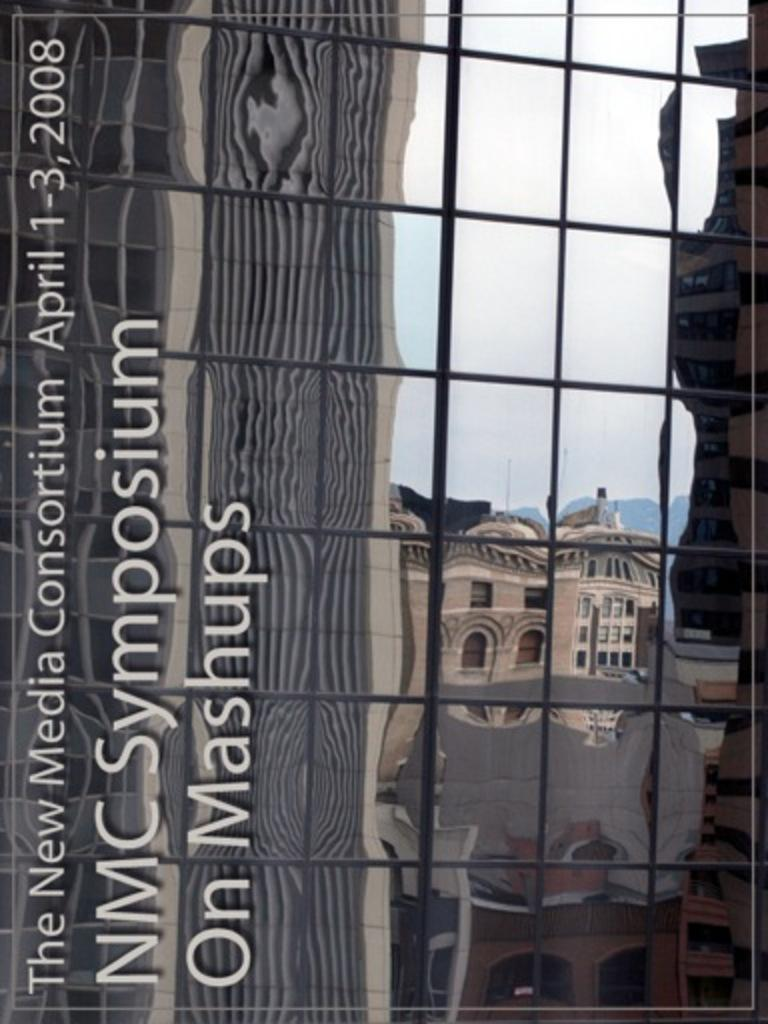What is located in the middle of the image? There is a glass in the middle of the image. What can be seen in the reflections on the glass? The glass has reflections of a few buildings. Is there any text present on the glass? Yes, there is text on the glass. Can you see a tent in the reflection on the glass? There is no tent visible in the reflection on the glass; it only shows reflections of a few buildings. 